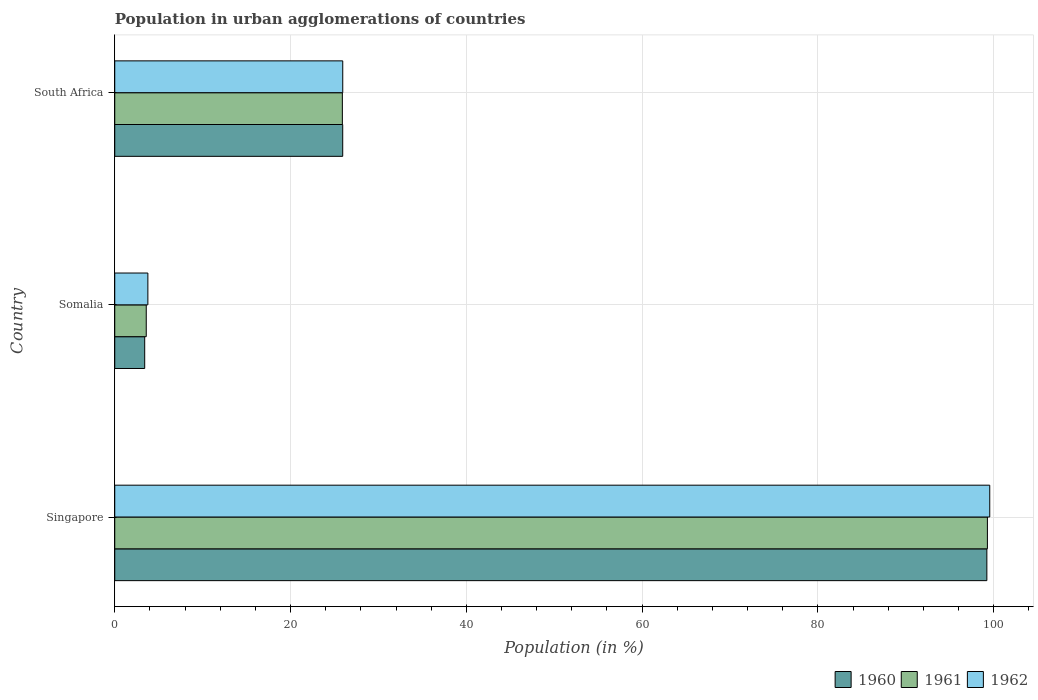How many different coloured bars are there?
Give a very brief answer. 3. How many groups of bars are there?
Provide a succinct answer. 3. Are the number of bars per tick equal to the number of legend labels?
Your answer should be compact. Yes. What is the label of the 3rd group of bars from the top?
Provide a short and direct response. Singapore. What is the percentage of population in urban agglomerations in 1960 in Singapore?
Provide a short and direct response. 99.23. Across all countries, what is the maximum percentage of population in urban agglomerations in 1961?
Offer a terse response. 99.29. Across all countries, what is the minimum percentage of population in urban agglomerations in 1961?
Provide a short and direct response. 3.58. In which country was the percentage of population in urban agglomerations in 1960 maximum?
Offer a very short reply. Singapore. In which country was the percentage of population in urban agglomerations in 1961 minimum?
Give a very brief answer. Somalia. What is the total percentage of population in urban agglomerations in 1961 in the graph?
Offer a very short reply. 128.77. What is the difference between the percentage of population in urban agglomerations in 1961 in Singapore and that in South Africa?
Provide a short and direct response. 73.4. What is the difference between the percentage of population in urban agglomerations in 1961 in Singapore and the percentage of population in urban agglomerations in 1960 in Somalia?
Your response must be concise. 95.88. What is the average percentage of population in urban agglomerations in 1962 per country?
Ensure brevity in your answer.  43.09. What is the difference between the percentage of population in urban agglomerations in 1960 and percentage of population in urban agglomerations in 1962 in Singapore?
Give a very brief answer. -0.33. What is the ratio of the percentage of population in urban agglomerations in 1962 in Singapore to that in Somalia?
Provide a short and direct response. 26.41. Is the percentage of population in urban agglomerations in 1960 in Singapore less than that in South Africa?
Keep it short and to the point. No. Is the difference between the percentage of population in urban agglomerations in 1960 in Somalia and South Africa greater than the difference between the percentage of population in urban agglomerations in 1962 in Somalia and South Africa?
Offer a terse response. No. What is the difference between the highest and the second highest percentage of population in urban agglomerations in 1962?
Ensure brevity in your answer.  73.62. What is the difference between the highest and the lowest percentage of population in urban agglomerations in 1960?
Ensure brevity in your answer.  95.82. Is the sum of the percentage of population in urban agglomerations in 1961 in Singapore and Somalia greater than the maximum percentage of population in urban agglomerations in 1960 across all countries?
Offer a very short reply. Yes. What does the 2nd bar from the top in Somalia represents?
Offer a terse response. 1961. How many bars are there?
Your answer should be compact. 9. Are all the bars in the graph horizontal?
Ensure brevity in your answer.  Yes. Are the values on the major ticks of X-axis written in scientific E-notation?
Keep it short and to the point. No. Does the graph contain any zero values?
Make the answer very short. No. Does the graph contain grids?
Provide a succinct answer. Yes. Where does the legend appear in the graph?
Your answer should be very brief. Bottom right. How many legend labels are there?
Your answer should be compact. 3. How are the legend labels stacked?
Provide a short and direct response. Horizontal. What is the title of the graph?
Keep it short and to the point. Population in urban agglomerations of countries. What is the label or title of the X-axis?
Ensure brevity in your answer.  Population (in %). What is the label or title of the Y-axis?
Your answer should be compact. Country. What is the Population (in %) of 1960 in Singapore?
Offer a very short reply. 99.23. What is the Population (in %) of 1961 in Singapore?
Make the answer very short. 99.29. What is the Population (in %) of 1962 in Singapore?
Make the answer very short. 99.56. What is the Population (in %) of 1960 in Somalia?
Provide a short and direct response. 3.41. What is the Population (in %) of 1961 in Somalia?
Your response must be concise. 3.58. What is the Population (in %) of 1962 in Somalia?
Your answer should be very brief. 3.77. What is the Population (in %) of 1960 in South Africa?
Give a very brief answer. 25.94. What is the Population (in %) of 1961 in South Africa?
Give a very brief answer. 25.9. What is the Population (in %) of 1962 in South Africa?
Offer a terse response. 25.94. Across all countries, what is the maximum Population (in %) in 1960?
Provide a succinct answer. 99.23. Across all countries, what is the maximum Population (in %) in 1961?
Your response must be concise. 99.29. Across all countries, what is the maximum Population (in %) in 1962?
Offer a terse response. 99.56. Across all countries, what is the minimum Population (in %) of 1960?
Your answer should be compact. 3.41. Across all countries, what is the minimum Population (in %) of 1961?
Make the answer very short. 3.58. Across all countries, what is the minimum Population (in %) in 1962?
Your answer should be compact. 3.77. What is the total Population (in %) in 1960 in the graph?
Your answer should be very brief. 128.58. What is the total Population (in %) in 1961 in the graph?
Provide a short and direct response. 128.77. What is the total Population (in %) of 1962 in the graph?
Your response must be concise. 129.27. What is the difference between the Population (in %) in 1960 in Singapore and that in Somalia?
Make the answer very short. 95.82. What is the difference between the Population (in %) of 1961 in Singapore and that in Somalia?
Provide a succinct answer. 95.71. What is the difference between the Population (in %) of 1962 in Singapore and that in Somalia?
Make the answer very short. 95.79. What is the difference between the Population (in %) of 1960 in Singapore and that in South Africa?
Give a very brief answer. 73.29. What is the difference between the Population (in %) of 1961 in Singapore and that in South Africa?
Give a very brief answer. 73.4. What is the difference between the Population (in %) of 1962 in Singapore and that in South Africa?
Provide a short and direct response. 73.62. What is the difference between the Population (in %) of 1960 in Somalia and that in South Africa?
Provide a succinct answer. -22.53. What is the difference between the Population (in %) in 1961 in Somalia and that in South Africa?
Ensure brevity in your answer.  -22.31. What is the difference between the Population (in %) in 1962 in Somalia and that in South Africa?
Your answer should be very brief. -22.17. What is the difference between the Population (in %) in 1960 in Singapore and the Population (in %) in 1961 in Somalia?
Your answer should be very brief. 95.65. What is the difference between the Population (in %) in 1960 in Singapore and the Population (in %) in 1962 in Somalia?
Make the answer very short. 95.46. What is the difference between the Population (in %) in 1961 in Singapore and the Population (in %) in 1962 in Somalia?
Your answer should be compact. 95.52. What is the difference between the Population (in %) in 1960 in Singapore and the Population (in %) in 1961 in South Africa?
Offer a terse response. 73.33. What is the difference between the Population (in %) of 1960 in Singapore and the Population (in %) of 1962 in South Africa?
Give a very brief answer. 73.29. What is the difference between the Population (in %) in 1961 in Singapore and the Population (in %) in 1962 in South Africa?
Keep it short and to the point. 73.35. What is the difference between the Population (in %) in 1960 in Somalia and the Population (in %) in 1961 in South Africa?
Make the answer very short. -22.49. What is the difference between the Population (in %) in 1960 in Somalia and the Population (in %) in 1962 in South Africa?
Keep it short and to the point. -22.53. What is the difference between the Population (in %) of 1961 in Somalia and the Population (in %) of 1962 in South Africa?
Offer a terse response. -22.36. What is the average Population (in %) of 1960 per country?
Give a very brief answer. 42.86. What is the average Population (in %) in 1961 per country?
Offer a terse response. 42.92. What is the average Population (in %) of 1962 per country?
Make the answer very short. 43.09. What is the difference between the Population (in %) of 1960 and Population (in %) of 1961 in Singapore?
Provide a short and direct response. -0.06. What is the difference between the Population (in %) in 1960 and Population (in %) in 1962 in Singapore?
Offer a very short reply. -0.33. What is the difference between the Population (in %) of 1961 and Population (in %) of 1962 in Singapore?
Provide a short and direct response. -0.27. What is the difference between the Population (in %) of 1960 and Population (in %) of 1961 in Somalia?
Your answer should be compact. -0.18. What is the difference between the Population (in %) in 1960 and Population (in %) in 1962 in Somalia?
Provide a short and direct response. -0.36. What is the difference between the Population (in %) in 1961 and Population (in %) in 1962 in Somalia?
Offer a very short reply. -0.19. What is the difference between the Population (in %) in 1960 and Population (in %) in 1961 in South Africa?
Keep it short and to the point. 0.04. What is the difference between the Population (in %) of 1960 and Population (in %) of 1962 in South Africa?
Keep it short and to the point. -0. What is the difference between the Population (in %) in 1961 and Population (in %) in 1962 in South Africa?
Ensure brevity in your answer.  -0.04. What is the ratio of the Population (in %) in 1960 in Singapore to that in Somalia?
Provide a succinct answer. 29.12. What is the ratio of the Population (in %) of 1961 in Singapore to that in Somalia?
Give a very brief answer. 27.7. What is the ratio of the Population (in %) in 1962 in Singapore to that in Somalia?
Your answer should be compact. 26.41. What is the ratio of the Population (in %) in 1960 in Singapore to that in South Africa?
Make the answer very short. 3.83. What is the ratio of the Population (in %) in 1961 in Singapore to that in South Africa?
Your response must be concise. 3.83. What is the ratio of the Population (in %) of 1962 in Singapore to that in South Africa?
Offer a very short reply. 3.84. What is the ratio of the Population (in %) of 1960 in Somalia to that in South Africa?
Your answer should be very brief. 0.13. What is the ratio of the Population (in %) of 1961 in Somalia to that in South Africa?
Keep it short and to the point. 0.14. What is the ratio of the Population (in %) of 1962 in Somalia to that in South Africa?
Your answer should be very brief. 0.15. What is the difference between the highest and the second highest Population (in %) of 1960?
Your answer should be very brief. 73.29. What is the difference between the highest and the second highest Population (in %) in 1961?
Offer a terse response. 73.4. What is the difference between the highest and the second highest Population (in %) of 1962?
Offer a very short reply. 73.62. What is the difference between the highest and the lowest Population (in %) in 1960?
Your answer should be very brief. 95.82. What is the difference between the highest and the lowest Population (in %) of 1961?
Make the answer very short. 95.71. What is the difference between the highest and the lowest Population (in %) in 1962?
Offer a very short reply. 95.79. 